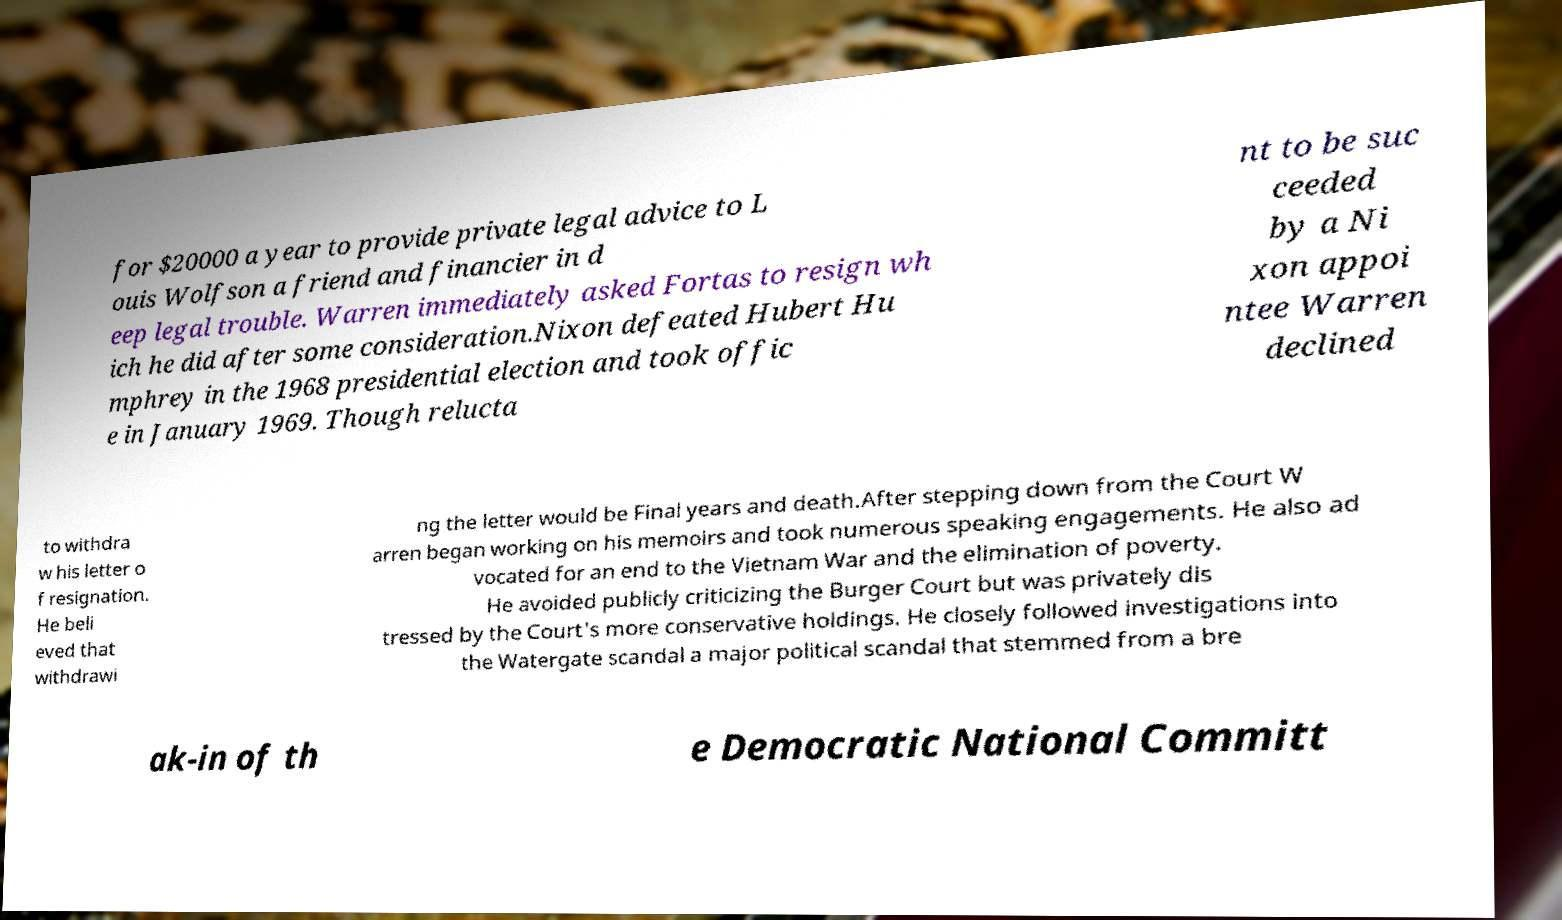Please identify and transcribe the text found in this image. for $20000 a year to provide private legal advice to L ouis Wolfson a friend and financier in d eep legal trouble. Warren immediately asked Fortas to resign wh ich he did after some consideration.Nixon defeated Hubert Hu mphrey in the 1968 presidential election and took offic e in January 1969. Though relucta nt to be suc ceeded by a Ni xon appoi ntee Warren declined to withdra w his letter o f resignation. He beli eved that withdrawi ng the letter would be Final years and death.After stepping down from the Court W arren began working on his memoirs and took numerous speaking engagements. He also ad vocated for an end to the Vietnam War and the elimination of poverty. He avoided publicly criticizing the Burger Court but was privately dis tressed by the Court's more conservative holdings. He closely followed investigations into the Watergate scandal a major political scandal that stemmed from a bre ak-in of th e Democratic National Committ 